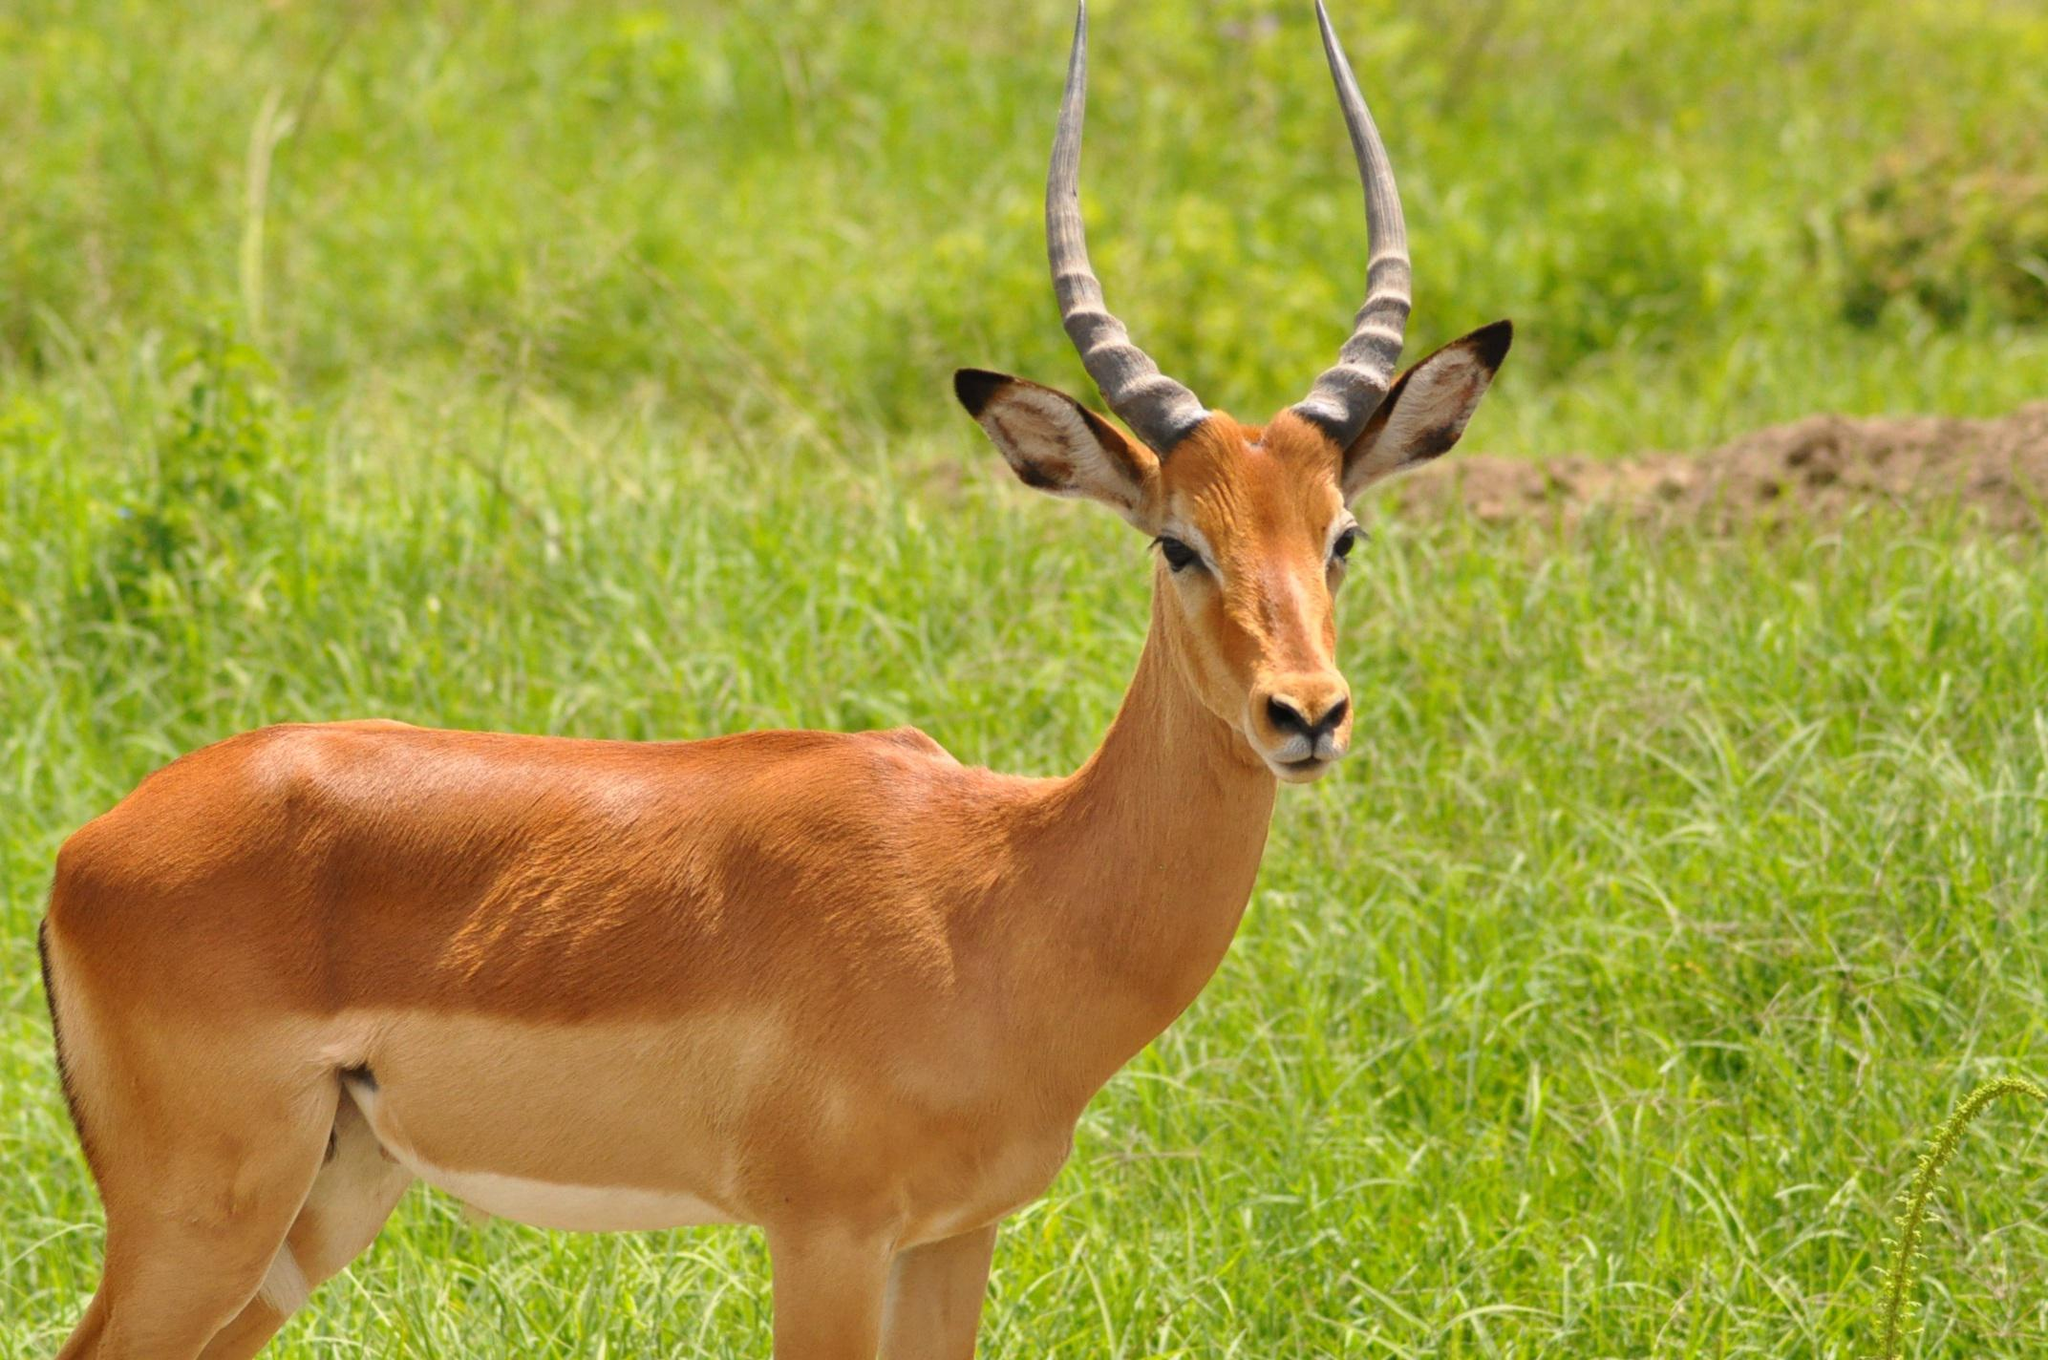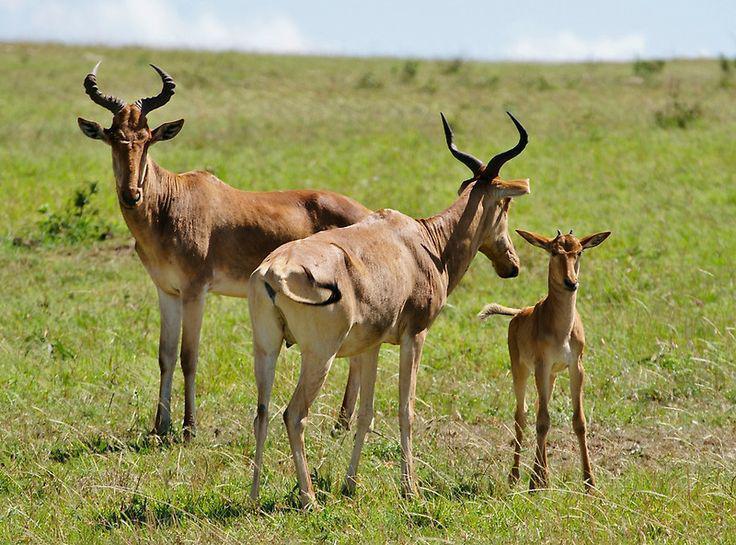The first image is the image on the left, the second image is the image on the right. For the images shown, is this caption "There are 3 animals." true? Answer yes or no. No. 